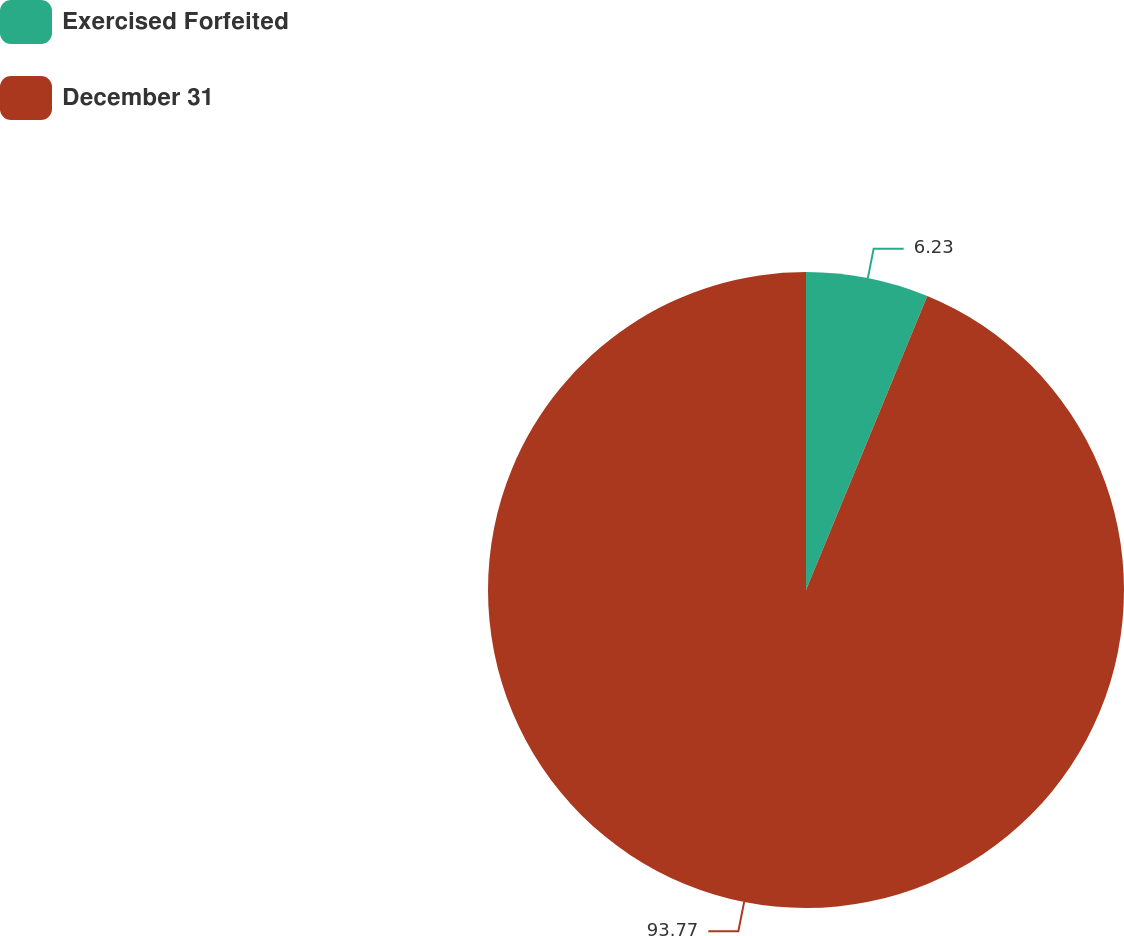<chart> <loc_0><loc_0><loc_500><loc_500><pie_chart><fcel>Exercised Forfeited<fcel>December 31<nl><fcel>6.23%<fcel>93.77%<nl></chart> 